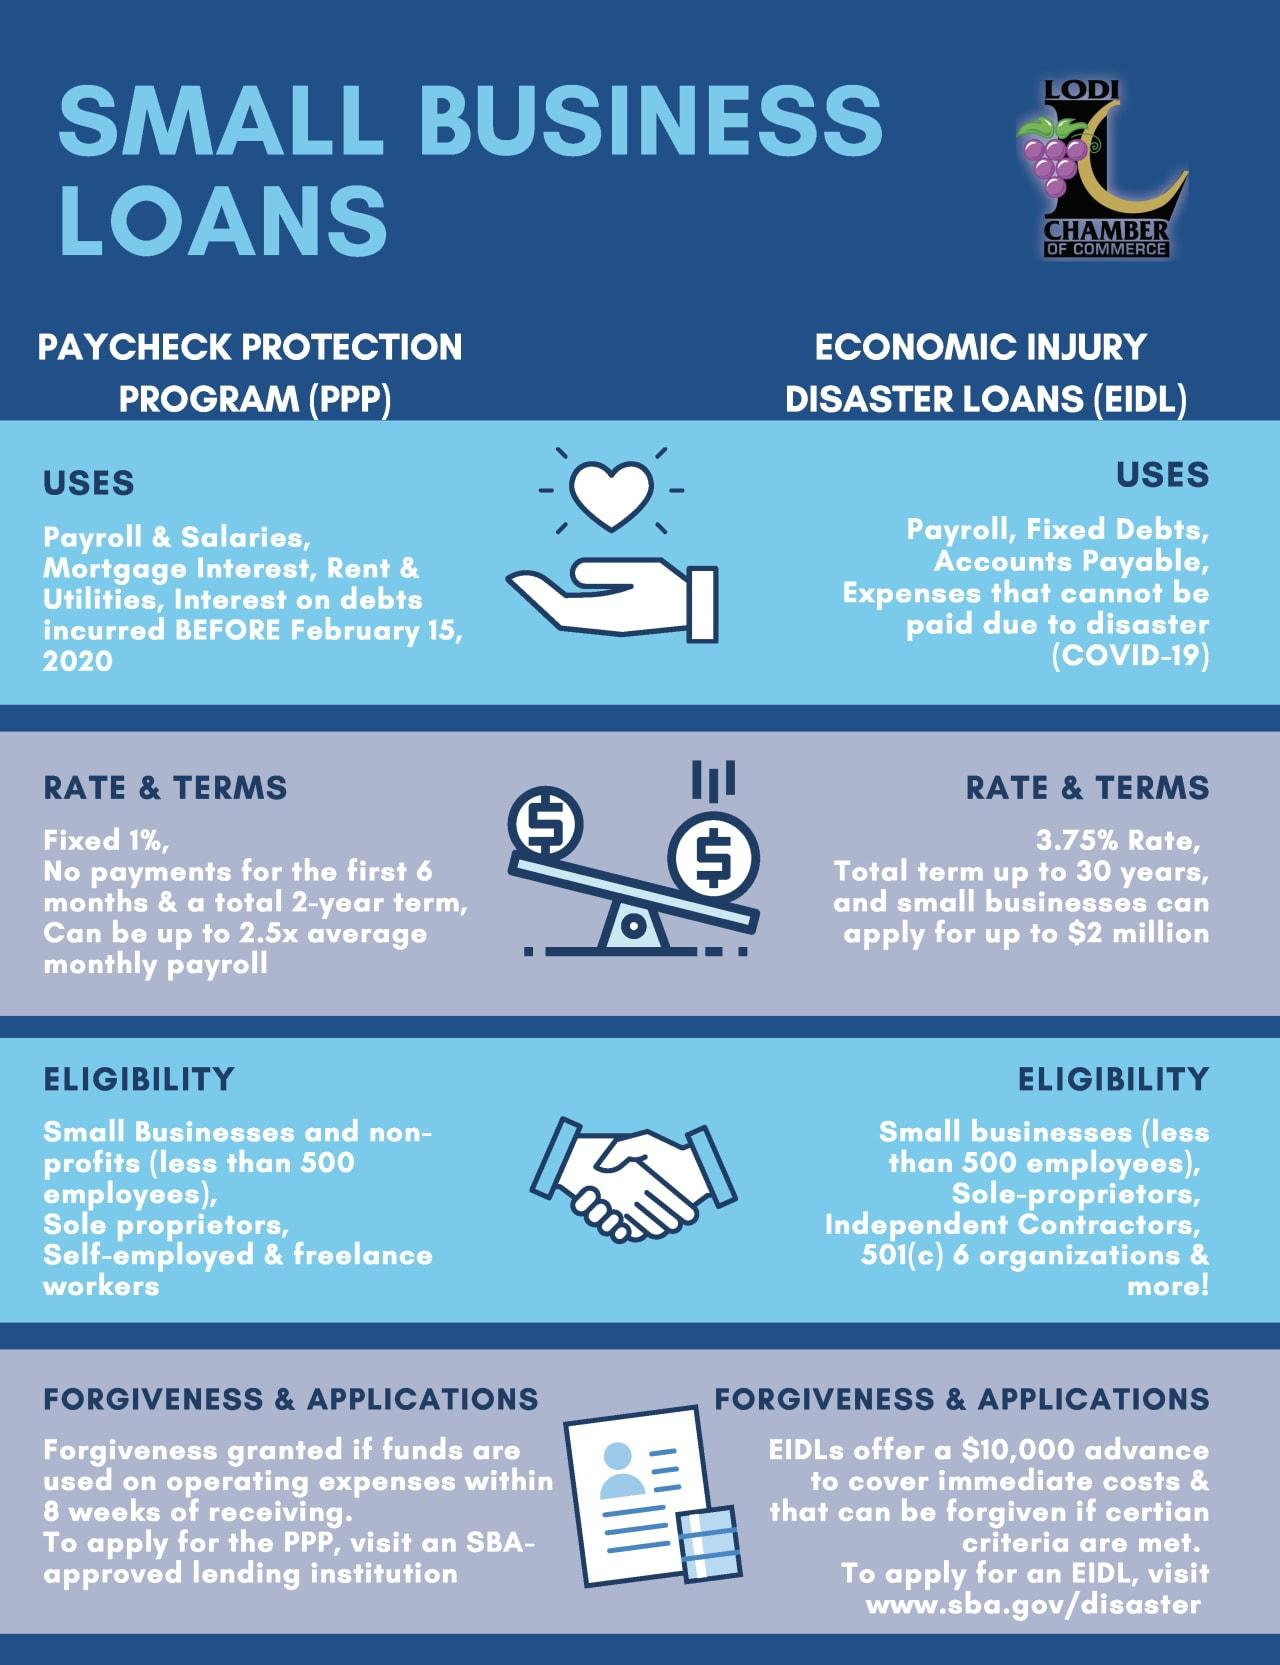Point out several critical features in this image. There are various types of small business loans, including paycheck protection programs and economic injury disaster loans. The infographic contains two types of small business loans. 